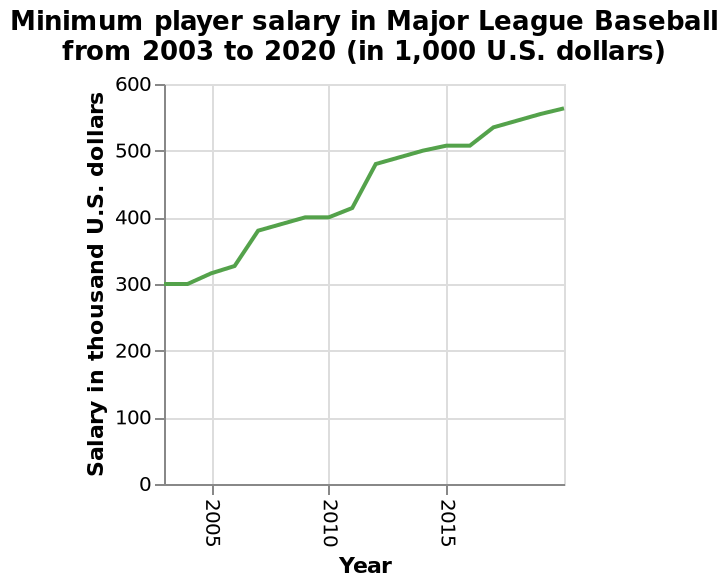<image>
What was the average annual growth rate of the salary during this period?  The average annual growth rate of the salary was approximately 5.94%. Describe the following image in detail Minimum player salary in Major League Baseball from 2003 to 2020 (in 1,000 U.S. dollars) is a line plot. There is a linear scale of range 0 to 600 on the y-axis, marked Salary in thousand U.S. dollars. Along the x-axis, Year is shown. 